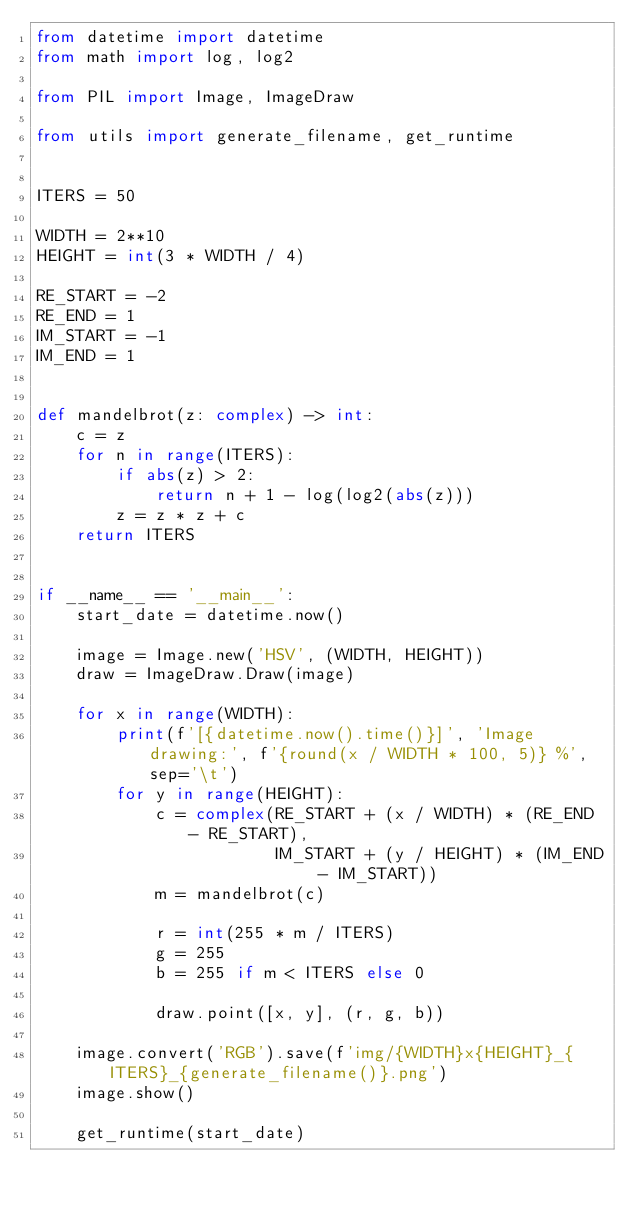Convert code to text. <code><loc_0><loc_0><loc_500><loc_500><_Python_>from datetime import datetime
from math import log, log2

from PIL import Image, ImageDraw

from utils import generate_filename, get_runtime


ITERS = 50

WIDTH = 2**10
HEIGHT = int(3 * WIDTH / 4)

RE_START = -2
RE_END = 1
IM_START = -1
IM_END = 1


def mandelbrot(z: complex) -> int:
    c = z
    for n in range(ITERS):
        if abs(z) > 2:
            return n + 1 - log(log2(abs(z)))
        z = z * z + c
    return ITERS


if __name__ == '__main__':
    start_date = datetime.now()

    image = Image.new('HSV', (WIDTH, HEIGHT))
    draw = ImageDraw.Draw(image)

    for x in range(WIDTH):
        print(f'[{datetime.now().time()}]', 'Image drawing:', f'{round(x / WIDTH * 100, 5)} %', sep='\t')
        for y in range(HEIGHT):
            c = complex(RE_START + (x / WIDTH) * (RE_END - RE_START),
                        IM_START + (y / HEIGHT) * (IM_END - IM_START))
            m = mandelbrot(c)

            r = int(255 * m / ITERS)
            g = 255
            b = 255 if m < ITERS else 0

            draw.point([x, y], (r, g, b))

    image.convert('RGB').save(f'img/{WIDTH}x{HEIGHT}_{ITERS}_{generate_filename()}.png')
    image.show()

    get_runtime(start_date)
</code> 